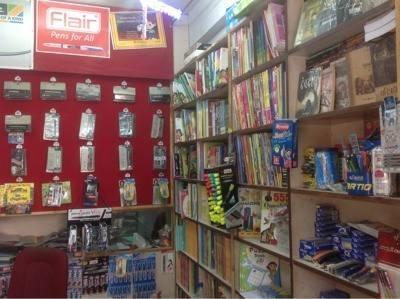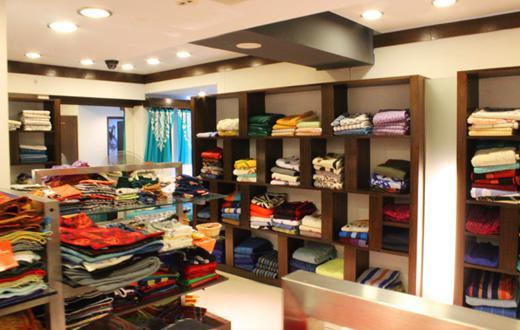The first image is the image on the left, the second image is the image on the right. For the images shown, is this caption "In the left image, books stacked flat are in front of books upright on rows of light-colored wood shelves, while the right image shows a variety of non-book items filling shelves on the walls." true? Answer yes or no. No. The first image is the image on the left, the second image is the image on the right. Evaluate the accuracy of this statement regarding the images: "There are books on a table.". Is it true? Answer yes or no. No. 